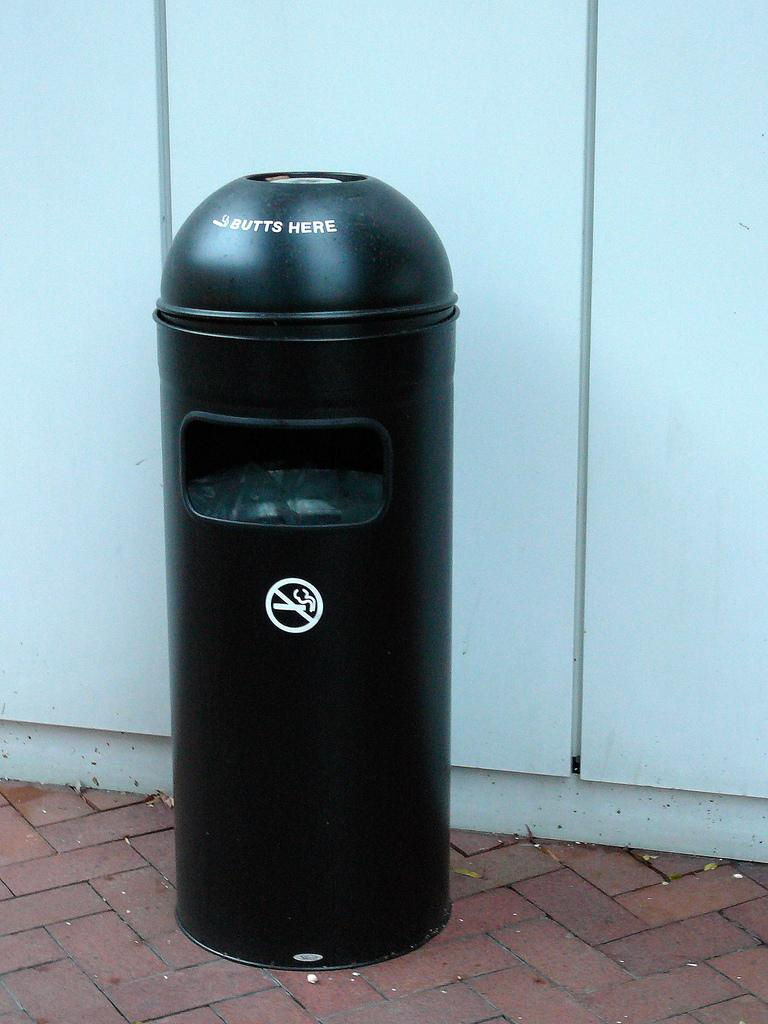<image>
Offer a succinct explanation of the picture presented. A black trashcan for cigarettes has the words "Butts Here" on it's lid. 